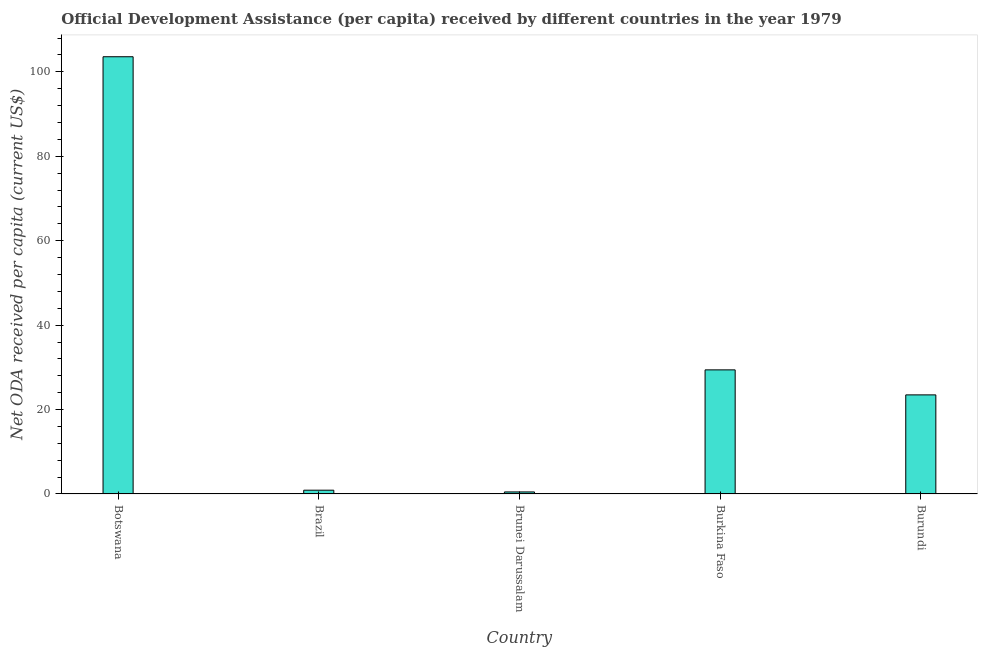Does the graph contain any zero values?
Offer a terse response. No. What is the title of the graph?
Ensure brevity in your answer.  Official Development Assistance (per capita) received by different countries in the year 1979. What is the label or title of the Y-axis?
Provide a short and direct response. Net ODA received per capita (current US$). What is the net oda received per capita in Brazil?
Your response must be concise. 0.89. Across all countries, what is the maximum net oda received per capita?
Ensure brevity in your answer.  103.59. Across all countries, what is the minimum net oda received per capita?
Ensure brevity in your answer.  0.48. In which country was the net oda received per capita maximum?
Keep it short and to the point. Botswana. In which country was the net oda received per capita minimum?
Your answer should be compact. Brunei Darussalam. What is the sum of the net oda received per capita?
Your answer should be compact. 157.84. What is the difference between the net oda received per capita in Brazil and Burundi?
Provide a succinct answer. -22.58. What is the average net oda received per capita per country?
Your answer should be very brief. 31.57. What is the median net oda received per capita?
Keep it short and to the point. 23.47. In how many countries, is the net oda received per capita greater than 52 US$?
Your answer should be compact. 1. What is the ratio of the net oda received per capita in Brunei Darussalam to that in Burundi?
Give a very brief answer. 0.02. Is the difference between the net oda received per capita in Brunei Darussalam and Burundi greater than the difference between any two countries?
Make the answer very short. No. What is the difference between the highest and the second highest net oda received per capita?
Provide a succinct answer. 74.19. Is the sum of the net oda received per capita in Brunei Darussalam and Burundi greater than the maximum net oda received per capita across all countries?
Provide a succinct answer. No. What is the difference between the highest and the lowest net oda received per capita?
Keep it short and to the point. 103.11. In how many countries, is the net oda received per capita greater than the average net oda received per capita taken over all countries?
Provide a succinct answer. 1. How many bars are there?
Provide a short and direct response. 5. What is the difference between two consecutive major ticks on the Y-axis?
Your answer should be very brief. 20. What is the Net ODA received per capita (current US$) of Botswana?
Make the answer very short. 103.59. What is the Net ODA received per capita (current US$) of Brazil?
Offer a very short reply. 0.89. What is the Net ODA received per capita (current US$) in Brunei Darussalam?
Keep it short and to the point. 0.48. What is the Net ODA received per capita (current US$) in Burkina Faso?
Offer a very short reply. 29.4. What is the Net ODA received per capita (current US$) in Burundi?
Provide a short and direct response. 23.47. What is the difference between the Net ODA received per capita (current US$) in Botswana and Brazil?
Offer a terse response. 102.7. What is the difference between the Net ODA received per capita (current US$) in Botswana and Brunei Darussalam?
Keep it short and to the point. 103.11. What is the difference between the Net ODA received per capita (current US$) in Botswana and Burkina Faso?
Offer a very short reply. 74.19. What is the difference between the Net ODA received per capita (current US$) in Botswana and Burundi?
Your answer should be compact. 80.11. What is the difference between the Net ODA received per capita (current US$) in Brazil and Brunei Darussalam?
Your answer should be compact. 0.41. What is the difference between the Net ODA received per capita (current US$) in Brazil and Burkina Faso?
Provide a succinct answer. -28.51. What is the difference between the Net ODA received per capita (current US$) in Brazil and Burundi?
Give a very brief answer. -22.58. What is the difference between the Net ODA received per capita (current US$) in Brunei Darussalam and Burkina Faso?
Your answer should be very brief. -28.92. What is the difference between the Net ODA received per capita (current US$) in Brunei Darussalam and Burundi?
Offer a very short reply. -22.99. What is the difference between the Net ODA received per capita (current US$) in Burkina Faso and Burundi?
Ensure brevity in your answer.  5.93. What is the ratio of the Net ODA received per capita (current US$) in Botswana to that in Brazil?
Offer a very short reply. 116. What is the ratio of the Net ODA received per capita (current US$) in Botswana to that in Brunei Darussalam?
Keep it short and to the point. 214.99. What is the ratio of the Net ODA received per capita (current US$) in Botswana to that in Burkina Faso?
Provide a short and direct response. 3.52. What is the ratio of the Net ODA received per capita (current US$) in Botswana to that in Burundi?
Keep it short and to the point. 4.41. What is the ratio of the Net ODA received per capita (current US$) in Brazil to that in Brunei Darussalam?
Your response must be concise. 1.85. What is the ratio of the Net ODA received per capita (current US$) in Brazil to that in Burkina Faso?
Ensure brevity in your answer.  0.03. What is the ratio of the Net ODA received per capita (current US$) in Brazil to that in Burundi?
Provide a succinct answer. 0.04. What is the ratio of the Net ODA received per capita (current US$) in Brunei Darussalam to that in Burkina Faso?
Your answer should be very brief. 0.02. What is the ratio of the Net ODA received per capita (current US$) in Brunei Darussalam to that in Burundi?
Keep it short and to the point. 0.02. What is the ratio of the Net ODA received per capita (current US$) in Burkina Faso to that in Burundi?
Your answer should be compact. 1.25. 